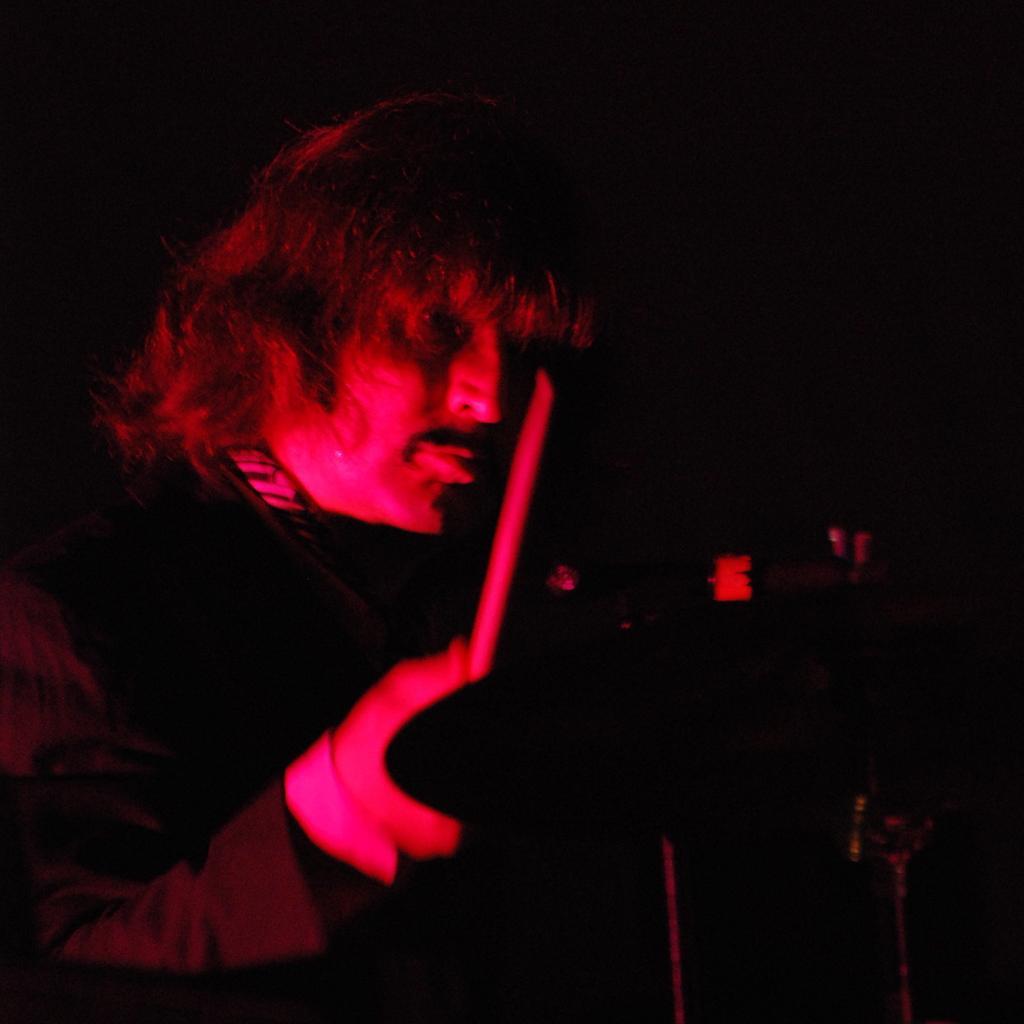Describe this image in one or two sentences. This is a dark image. We can see a man is holding a stick in his hand and on the right there is an object. 